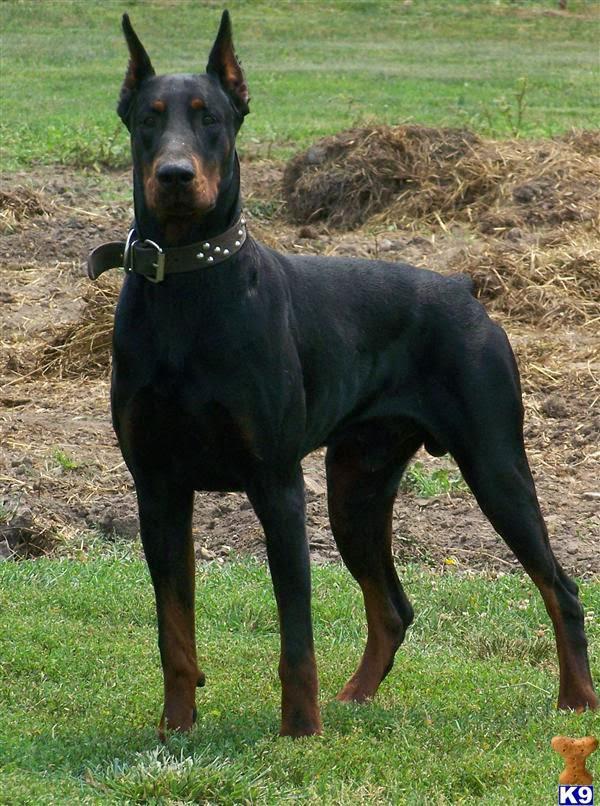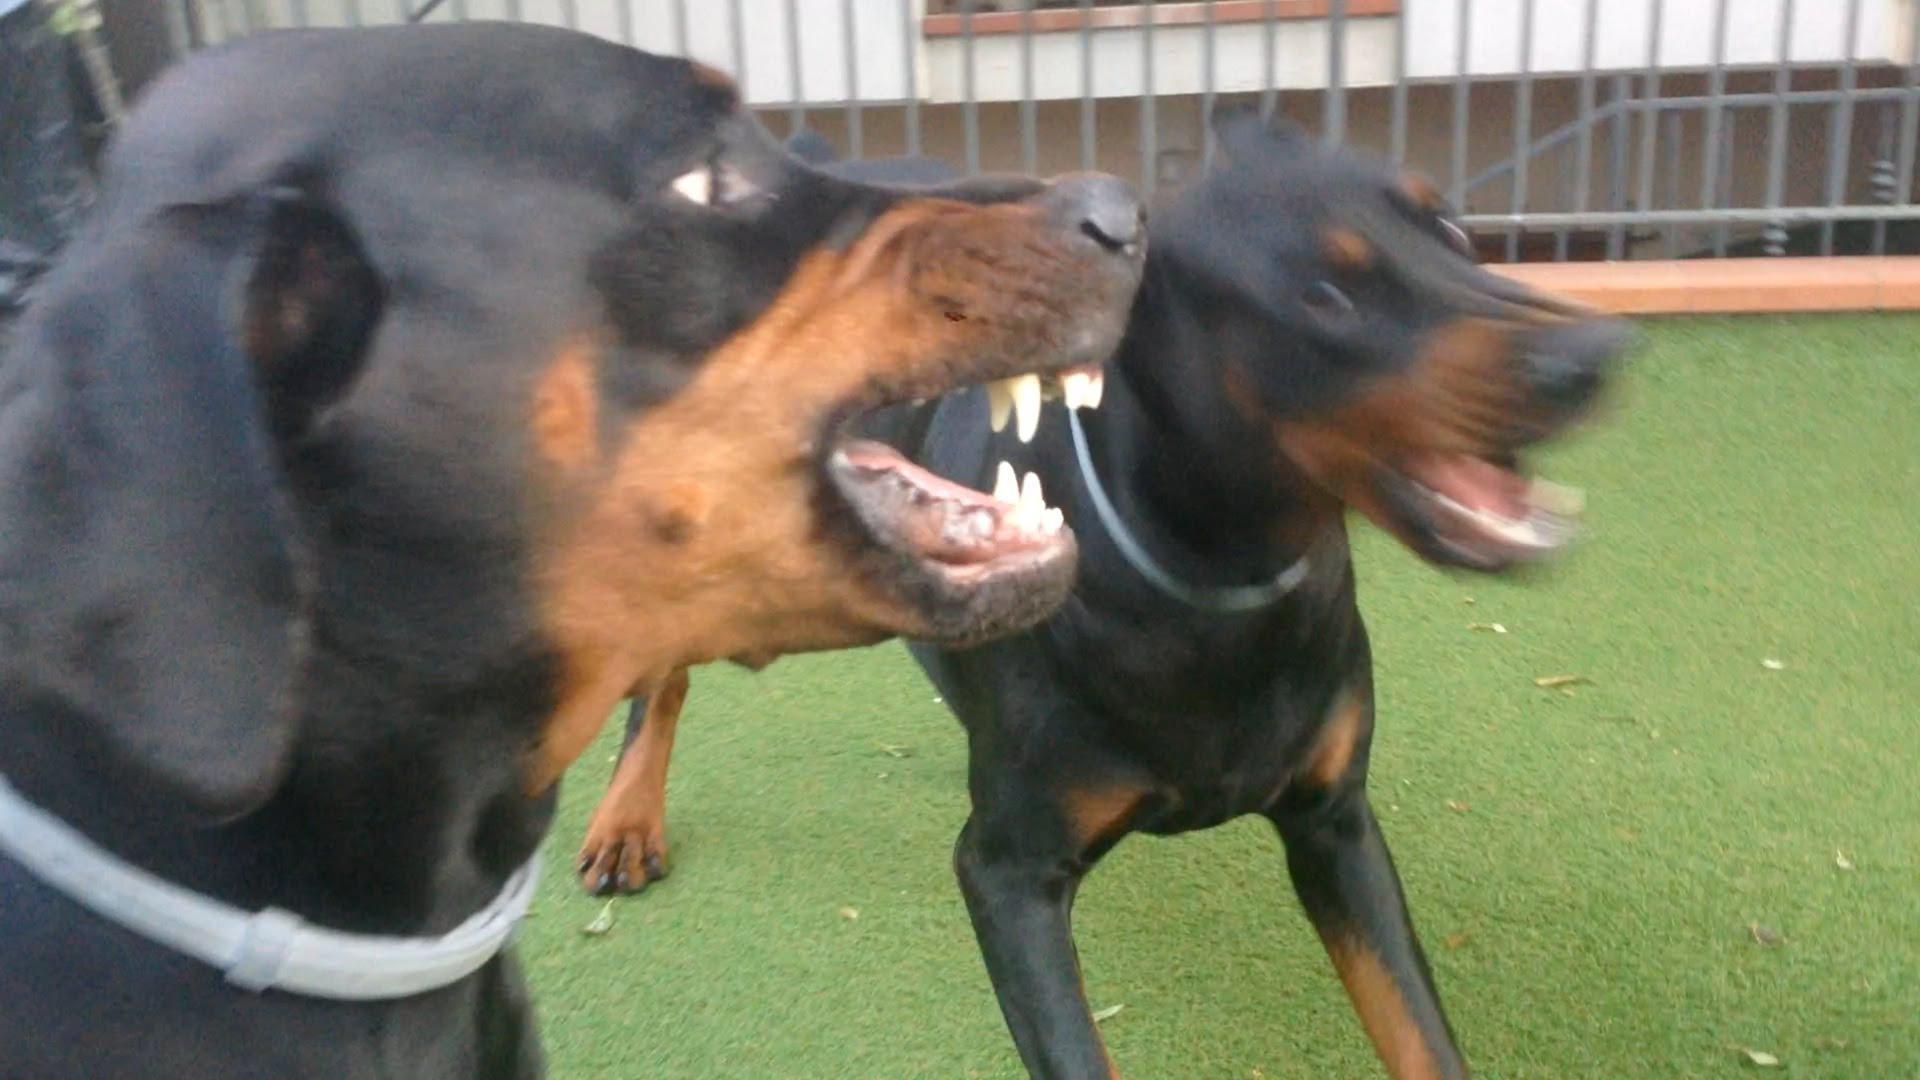The first image is the image on the left, the second image is the image on the right. Given the left and right images, does the statement "The left image contains exactly one dog." hold true? Answer yes or no. Yes. 